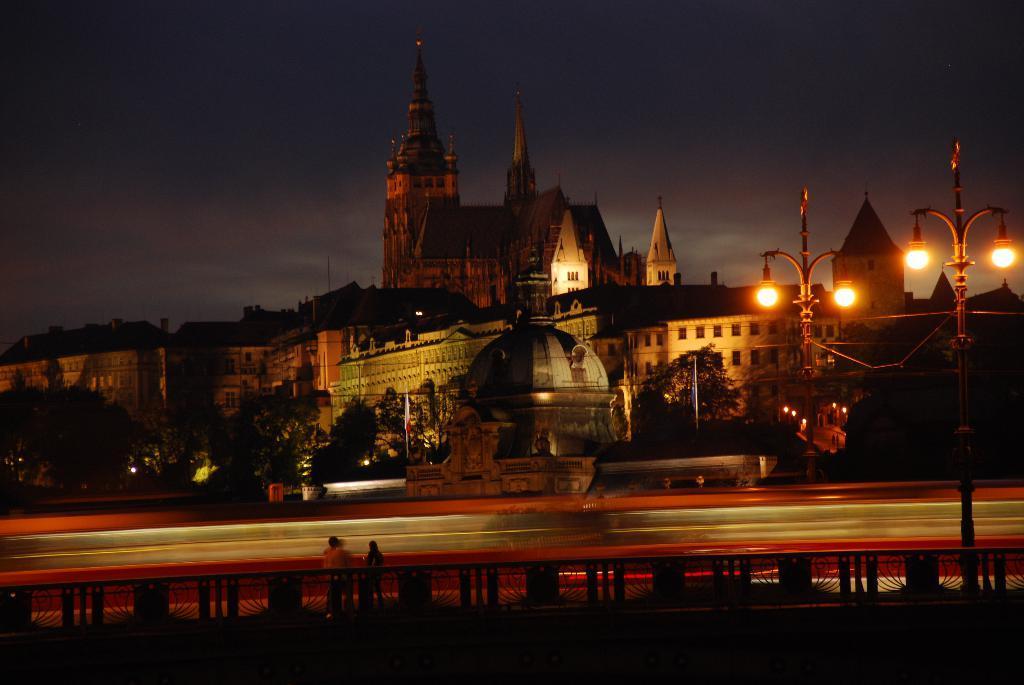Describe this image in one or two sentences. In this image I can see few persons standing and I can also see few light poles. In the background I can see few buildings and the sky is in blue and white color. 